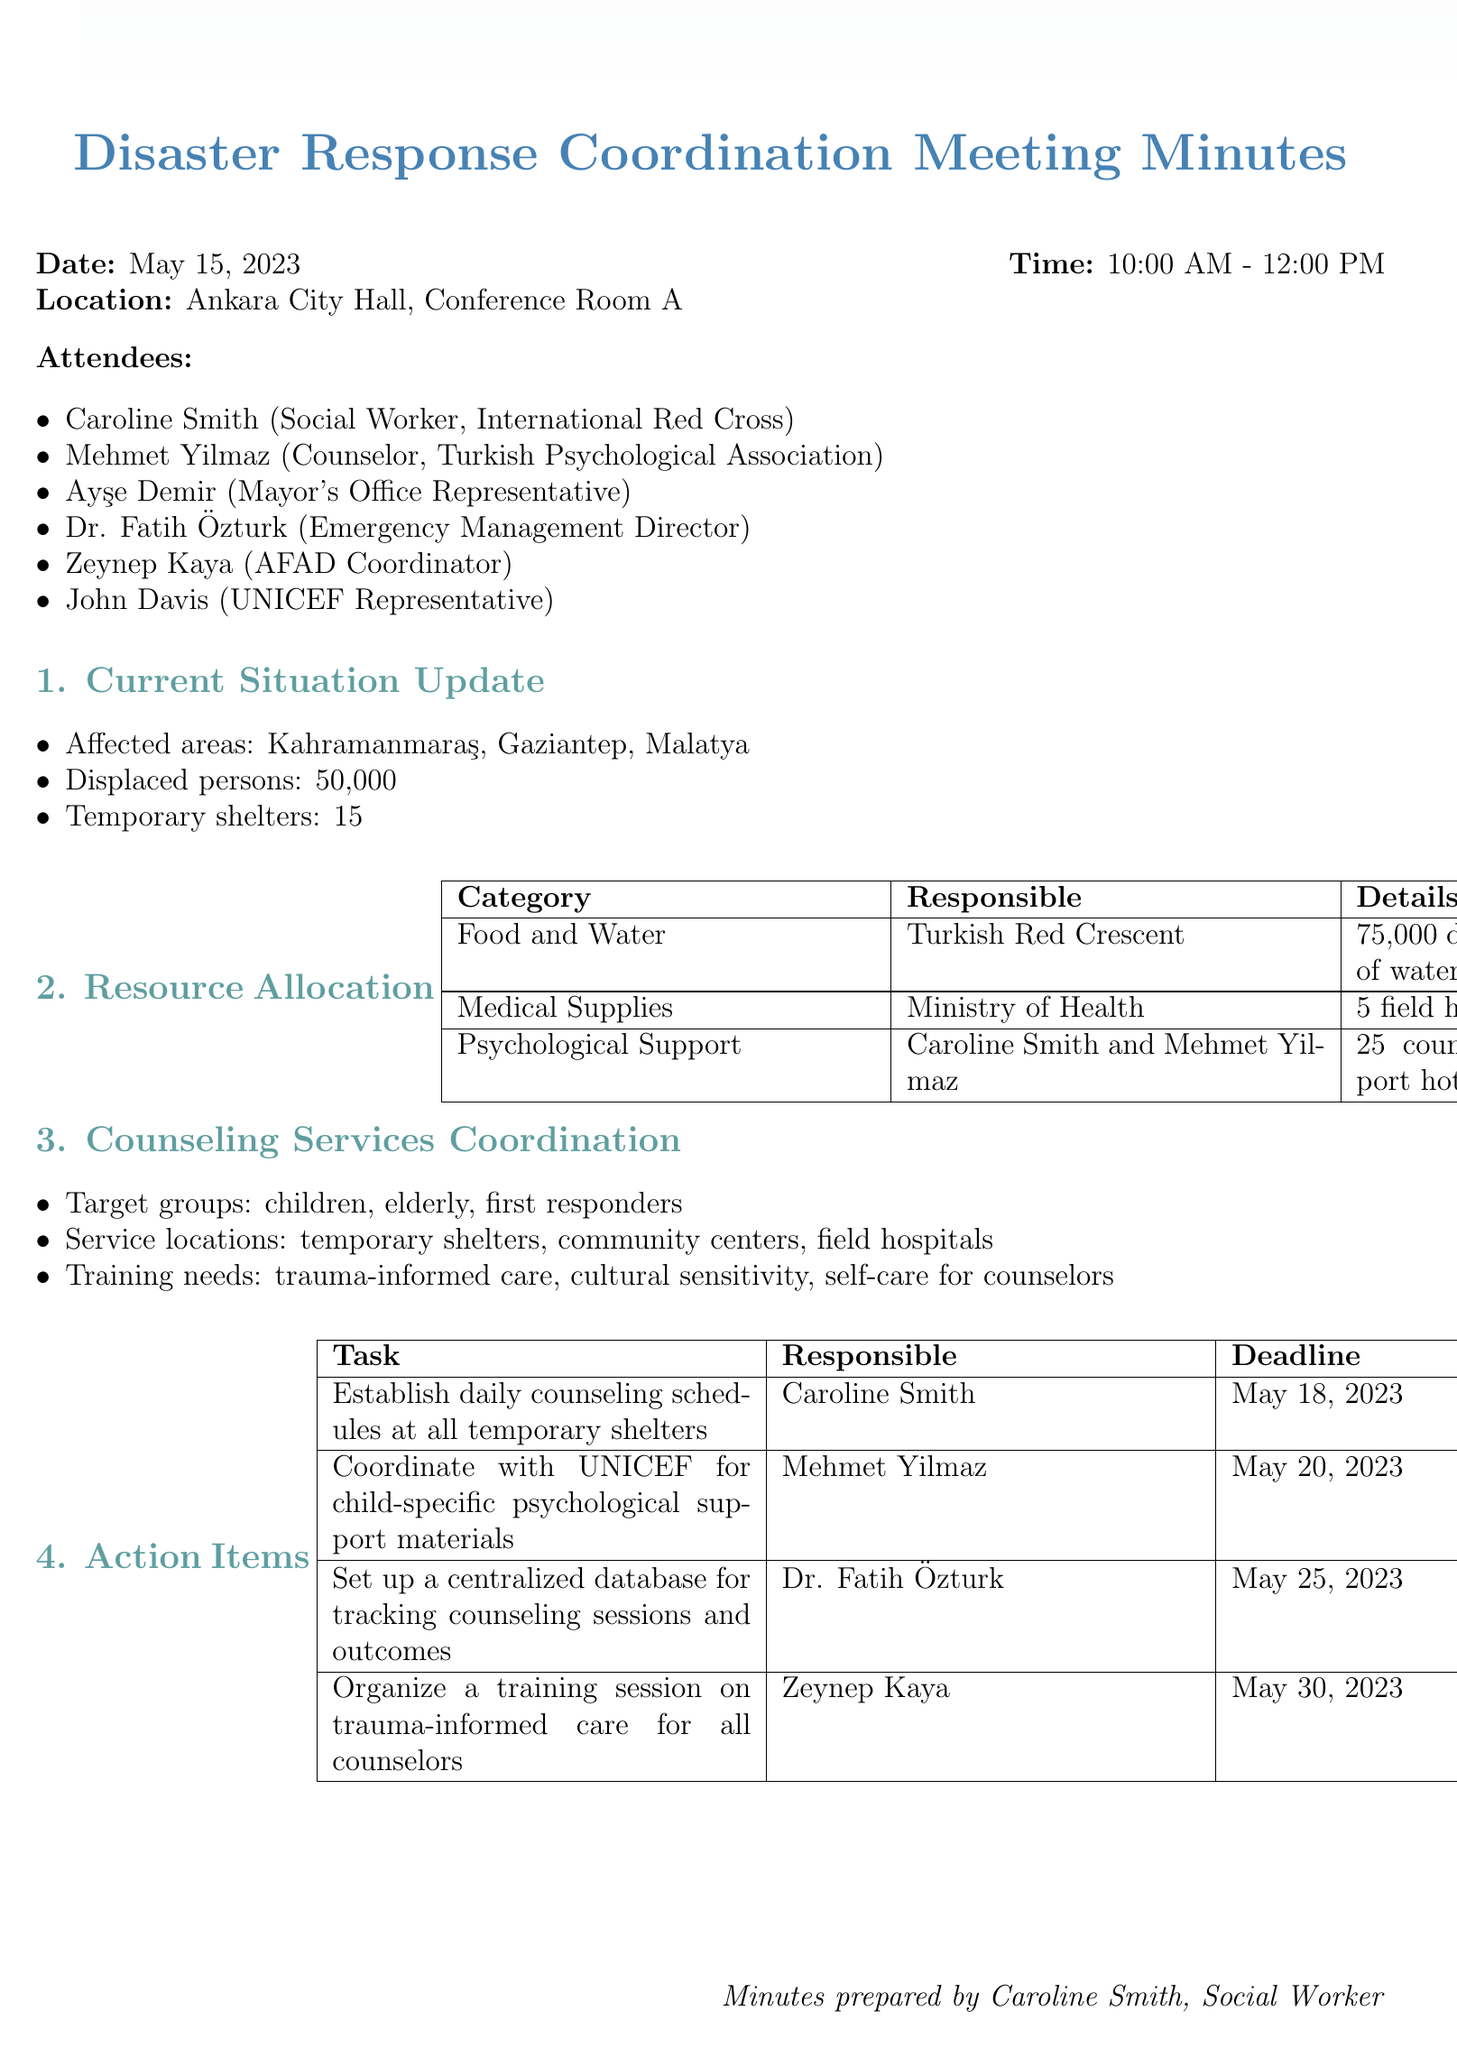What is the date of the meeting? The date of the meeting is clearly stated in the document.
Answer: May 15, 2023 How many displaced persons are reported? The number of displaced persons is indicated in the situation update section of the document.
Answer: 50000 Who is responsible for coordinating psychological support? The responsible individuals for psychological support are mentioned in the resource allocation section.
Answer: Caroline Smith and Mehmet Yilmaz What is the deadline for establishing daily counseling schedules? The deadline for this task is listed in the action items section of the document.
Answer: May 18, 2023 What are the target groups for counseling services? The target groups are specified in the counseling services coordination section of the document.
Answer: children, elderly, first responders How many field hospitals are reported to be available? The number of field hospitals is specified in the resource allocation section.
Answer: 5 What is one of the training needs mentioned for counselors? The document specifies training needs in the counseling services coordination section.
Answer: trauma-informed care What task is Zeynep Kaya responsible for? Zeynep Kaya's responsibility is listed in the action items section.
Answer: Organize a training session on trauma-informed care for all counselors 